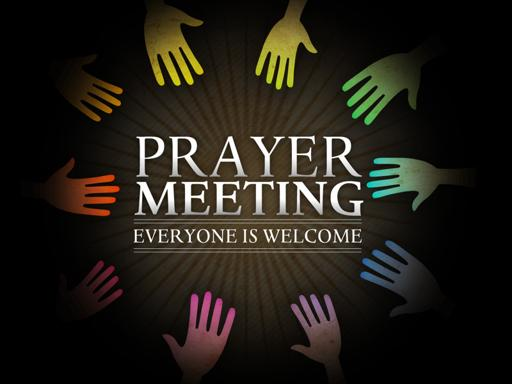What impact might this type of gathering have on the community? This type of gathering could significantly enhance community bonds by bringing people together in a shared, spiritually meaningful activity. It could foster mutual understanding and support among participants, potentially leading to stronger community cohesion and increased social support networks. Are there specific themes or prayers that would be focused on during such a meeting? Typically, such meetings might focus on themes of forgiveness, peace, and community well-being. Prayers may also be centered on personal growth, healing, and gratitude, reflecting common desires and concerns within the community, thereby enhancing the relevance and impact of the gathering. 